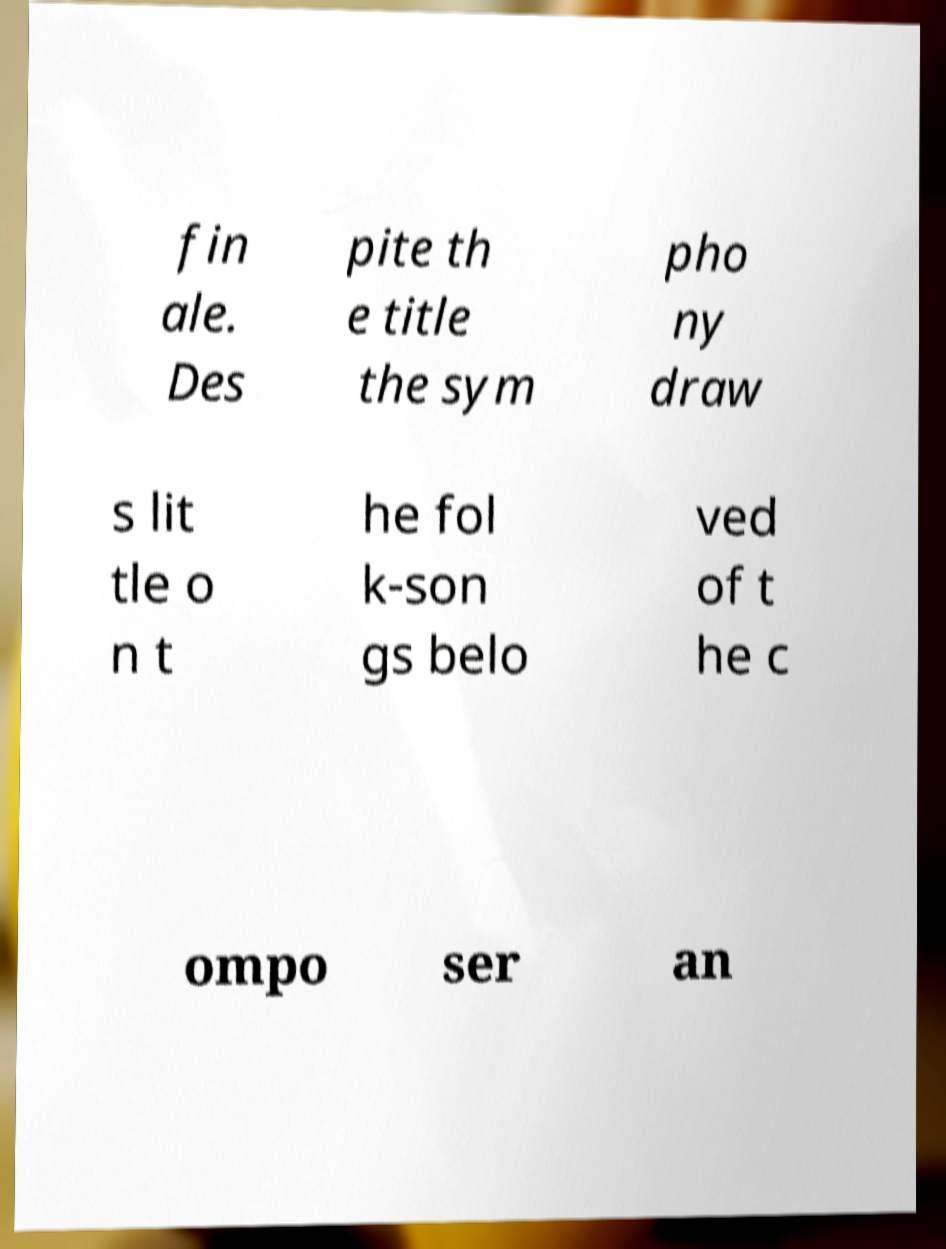There's text embedded in this image that I need extracted. Can you transcribe it verbatim? fin ale. Des pite th e title the sym pho ny draw s lit tle o n t he fol k-son gs belo ved of t he c ompo ser an 